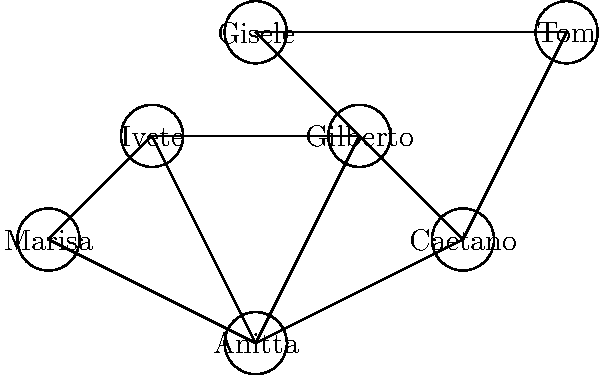In this social network diagram of Brazilian celebrities, what is the shortest path between Anitta and Tom Jobim, and how many connections does it involve? To find the shortest path between Anitta and Tom Jobim, we need to count the minimum number of connections (edges) between them. Let's explore the possible paths:

1. Anitta → Caetano → Tom
   This path involves 2 connections.

2. Anitta → Gilberto → Gisele → Tom
   This path involves 3 connections.

3. Anitta → Ivete → Gilberto → Gisele → Tom
   This path involves 4 connections.

4. Anitta → Marisa → Ivete → Gilberto → Gisele → Tom
   This path involves 5 connections.

The shortest path is the first one: Anitta → Caetano → Tom, which involves 2 connections.
Answer: Anitta → Caetano → Tom, 2 connections 